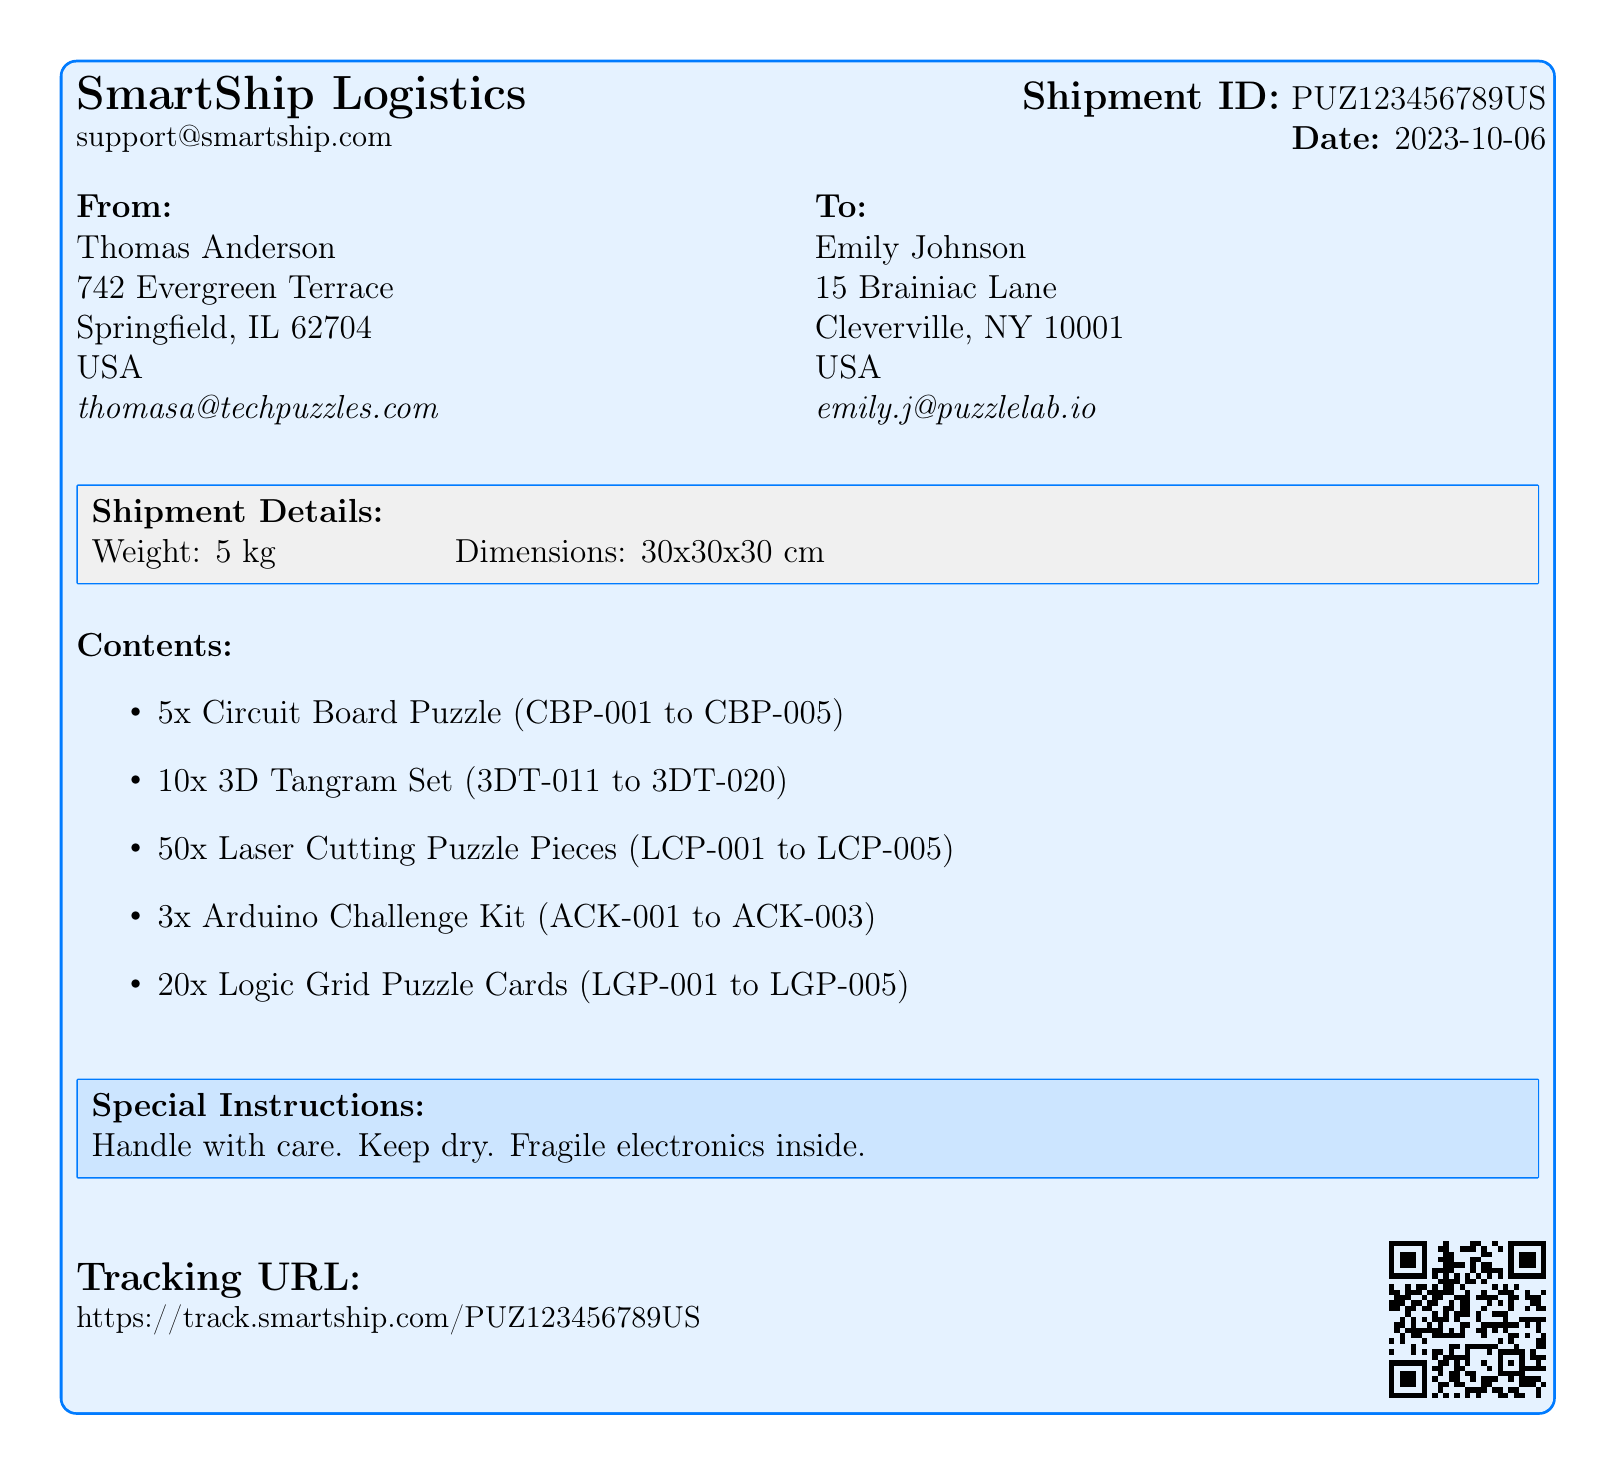What is the Shipment ID? The Shipment ID is found in the document and identifies the package for tracking purposes.
Answer: PUZ123456789US What is the weight of the shipment? The weight of the shipment is specified in the shipment details section.
Answer: 5 kg Who is the sender? The sender's information is provided in the document which includes their name and address.
Answer: Thomas Anderson What are the contents of the shipment? The contents are listed under the "Contents" section and detail the items included in the shipment.
Answer: 5x Circuit Board Puzzle, 10x 3D Tangram Set, 50x Laser Cutting Puzzle Pieces, 3x Arduino Challenge Kit, 20x Logic Grid Puzzle Cards What is the tracking URL? The tracking URL is mentioned in the document for tracking the shipment online.
Answer: https://track.smartship.com/PUZ123456789US What special instructions are provided for the shipment? The special instructions highlight important handling information for the package.
Answer: Handle with care. Keep dry. Fragile electronics inside What is the date of shipment? The shipment date is noted in the top-right section of the document.
Answer: 2023-10-06 What is the total number of puzzle kits included? The total number of items in the shipment is calculated from the contents listed.
Answer: 98 